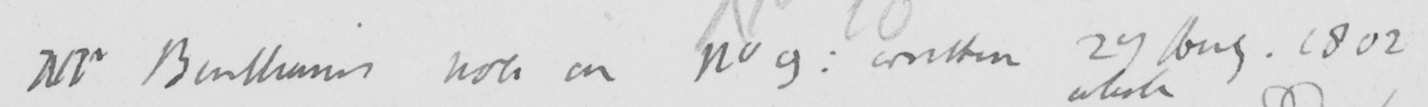Can you tell me what this handwritten text says? Mr Bentham ' s note on No 9 :  written 27 Aug . 1802 